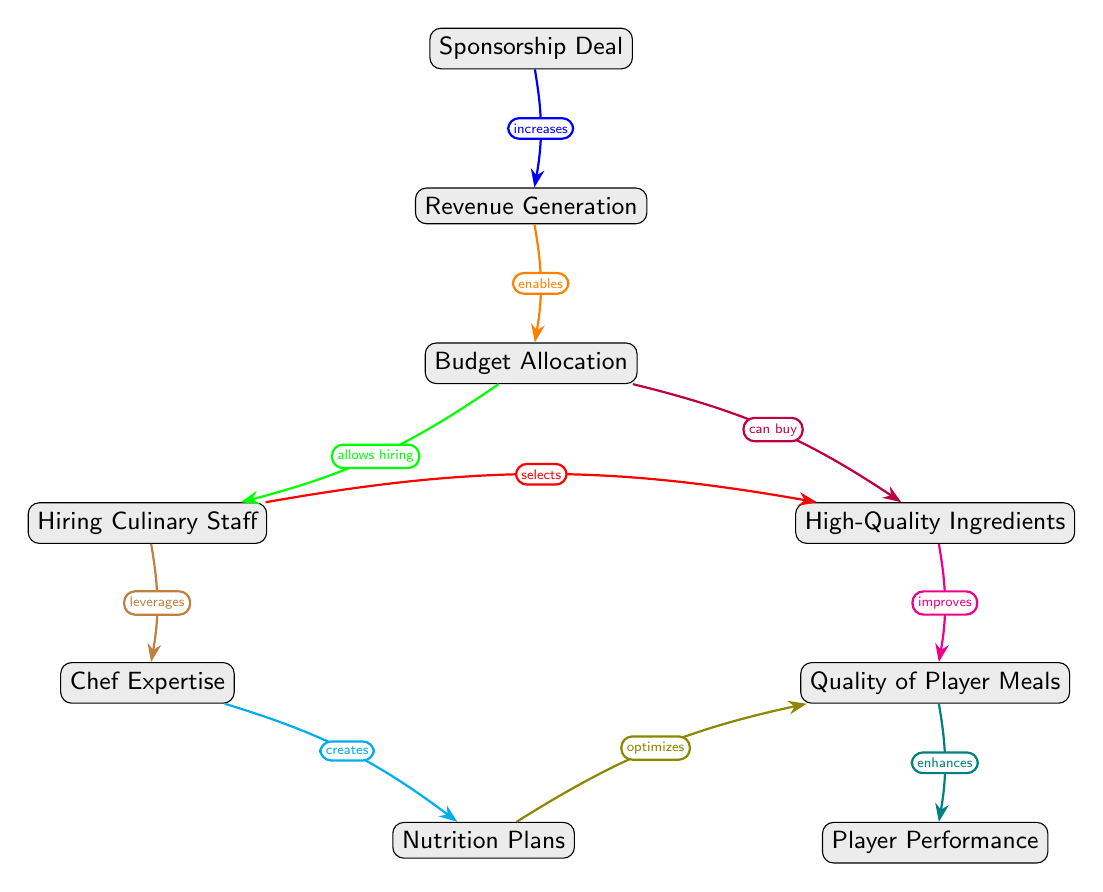What is the first node in the diagram? The first node at the top of the diagram is "Sponsorship Deal." It is where the sequence begins, indicating that everything stems from the sponsorship aspect.
Answer: Sponsorship Deal How many nodes are in the diagram? The diagram contains a total of 9 nodes, which include all the distinct concepts representing different stages from sponsorship deals down to player performance.
Answer: 9 What relationship does "Budget Allocation" have with "High-Quality Ingredients"? "Budget Allocation" allows for the purchasing of "High-Quality Ingredients," as shown by the directed edge indicating that the budget can be used in this manner.
Answer: allows buying Which node improves the "Quality of Player Meals"? The node "High-Quality Ingredients" improves "Quality of Player Meals" according to the flow of the diagram, highlighting its influence on meal quality.
Answer: High-Quality Ingredients What node is directly influenced by "Nutrition Plans"? The node directly influenced by "Nutrition Plans" is "Quality of Player Meals." The arrow indicates that nutrition plans optimize meal quality, showing a direct relationship.
Answer: Quality of Player Meals What is the last node in the diagram? The last node in the diagram is "Player Performance," which is the outcome of all previous factors related to sponsorship deals, budget allocation, and meal quality.
Answer: Player Performance How does "Sponsorship Deal" affect "Player Performance"? "Sponsorship Deal" increases revenue generation which, through various allocations and adjustments, eventually leads to enhanced player performance through improved meals.
Answer: enhances What role does "Culinary Staff" play in relation to "High-Quality Ingredients"? "Culinary Staff" selects and works with "High-Quality Ingredients," indicating their crucial role in determining the quality of the ingredients used in player meals.
Answer: selects Which element is responsible for creating Nutrition Plans? "Chef Expertise" is responsible for creating Nutrition Plans, as indicated by the direct relationship between these nodes showing the knowledge used to construct meal plans.
Answer: Chef Expertise 